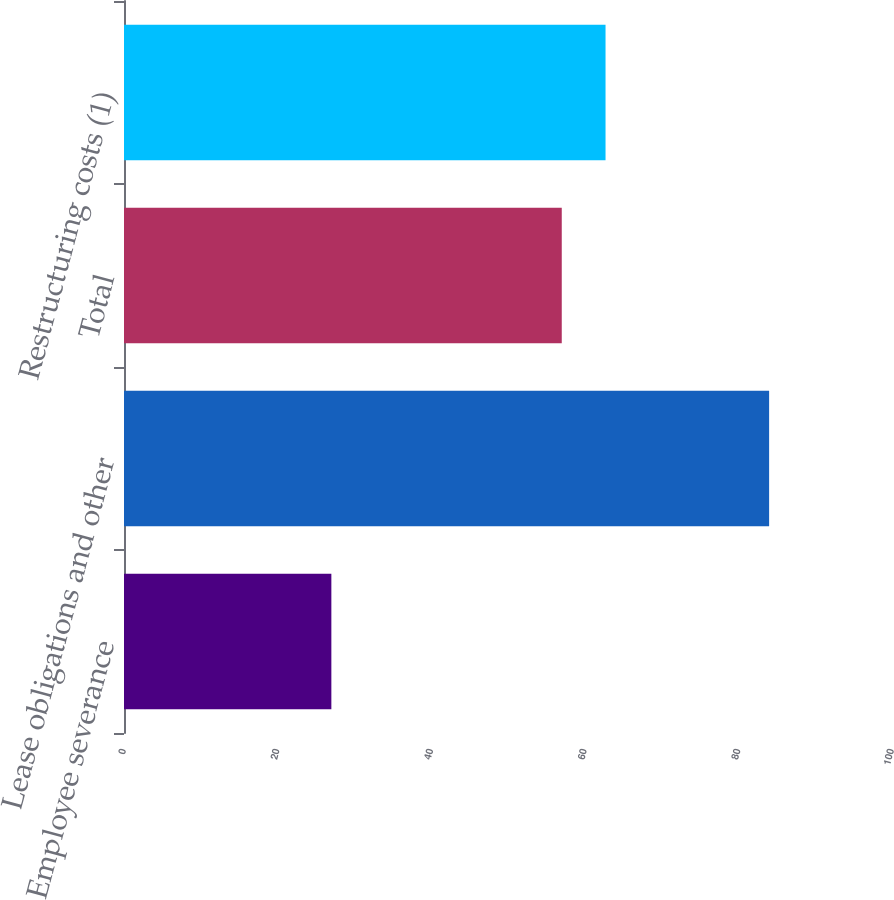<chart> <loc_0><loc_0><loc_500><loc_500><bar_chart><fcel>Employee severance<fcel>Lease obligations and other<fcel>Total<fcel>Restructuring costs (1)<nl><fcel>27<fcel>84<fcel>57<fcel>62.7<nl></chart> 